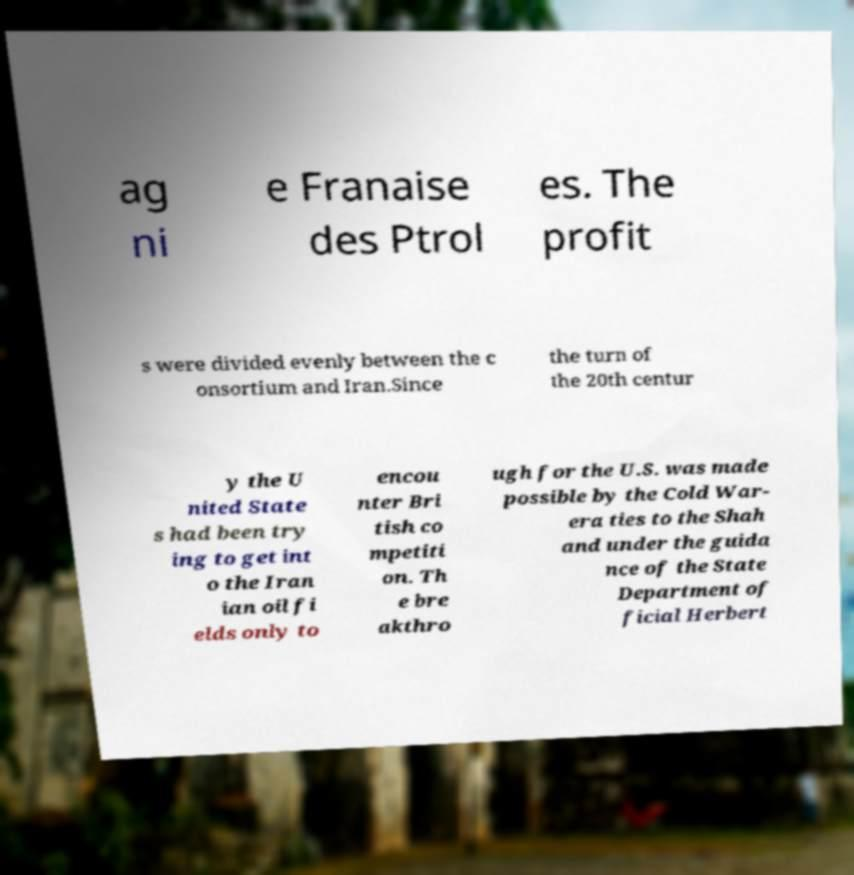For documentation purposes, I need the text within this image transcribed. Could you provide that? ag ni e Franaise des Ptrol es. The profit s were divided evenly between the c onsortium and Iran.Since the turn of the 20th centur y the U nited State s had been try ing to get int o the Iran ian oil fi elds only to encou nter Bri tish co mpetiti on. Th e bre akthro ugh for the U.S. was made possible by the Cold War- era ties to the Shah and under the guida nce of the State Department of ficial Herbert 